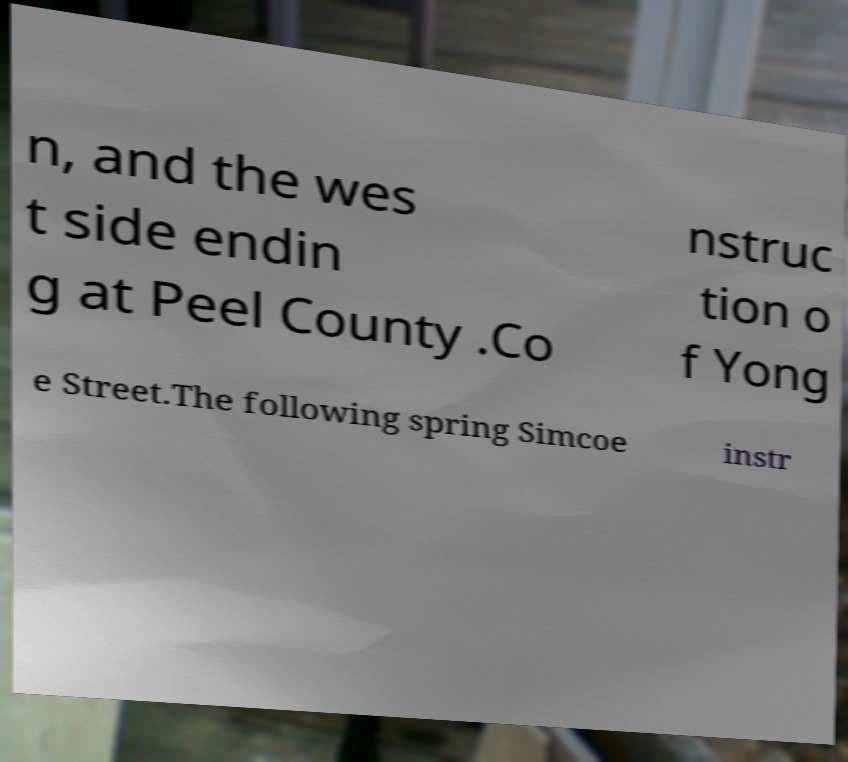Can you accurately transcribe the text from the provided image for me? n, and the wes t side endin g at Peel County .Co nstruc tion o f Yong e Street.The following spring Simcoe instr 